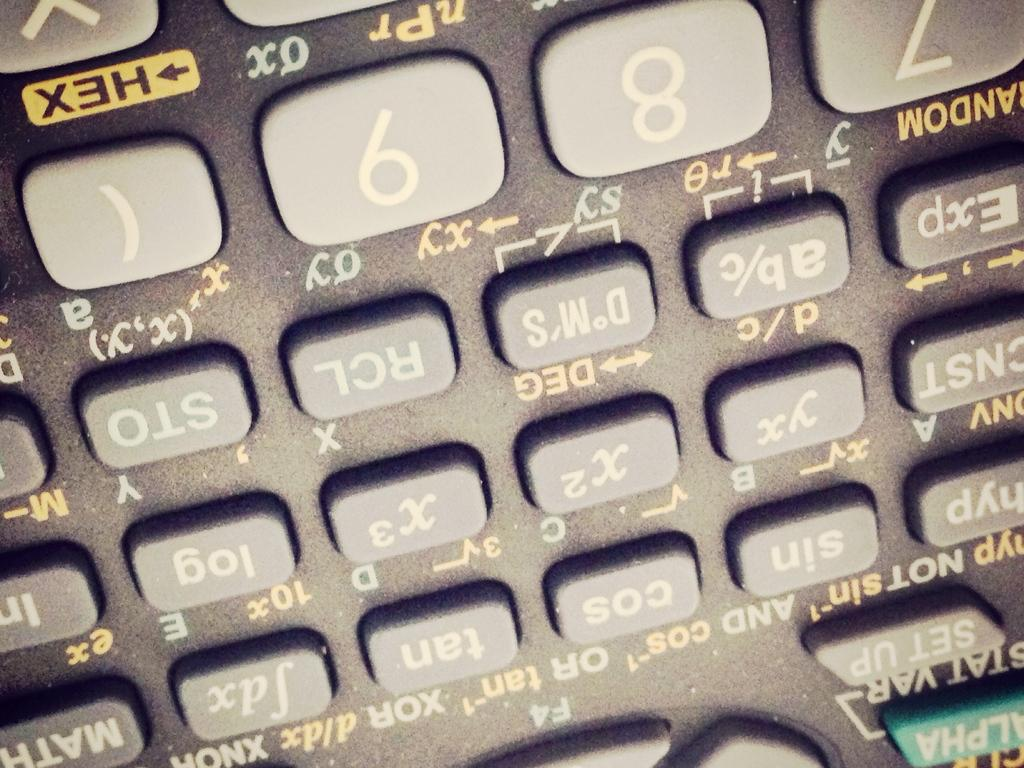What type of buttons are visible in the image? There are number calculator buttons in the image. What might these buttons be used for? These buttons might be used for performing calculations or mathematical operations. Who is the creator of the badge shown in the image? There is no badge present in the image; it only features number calculator buttons. 